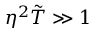Convert formula to latex. <formula><loc_0><loc_0><loc_500><loc_500>\eta ^ { 2 } \tilde { T } \gg 1</formula> 